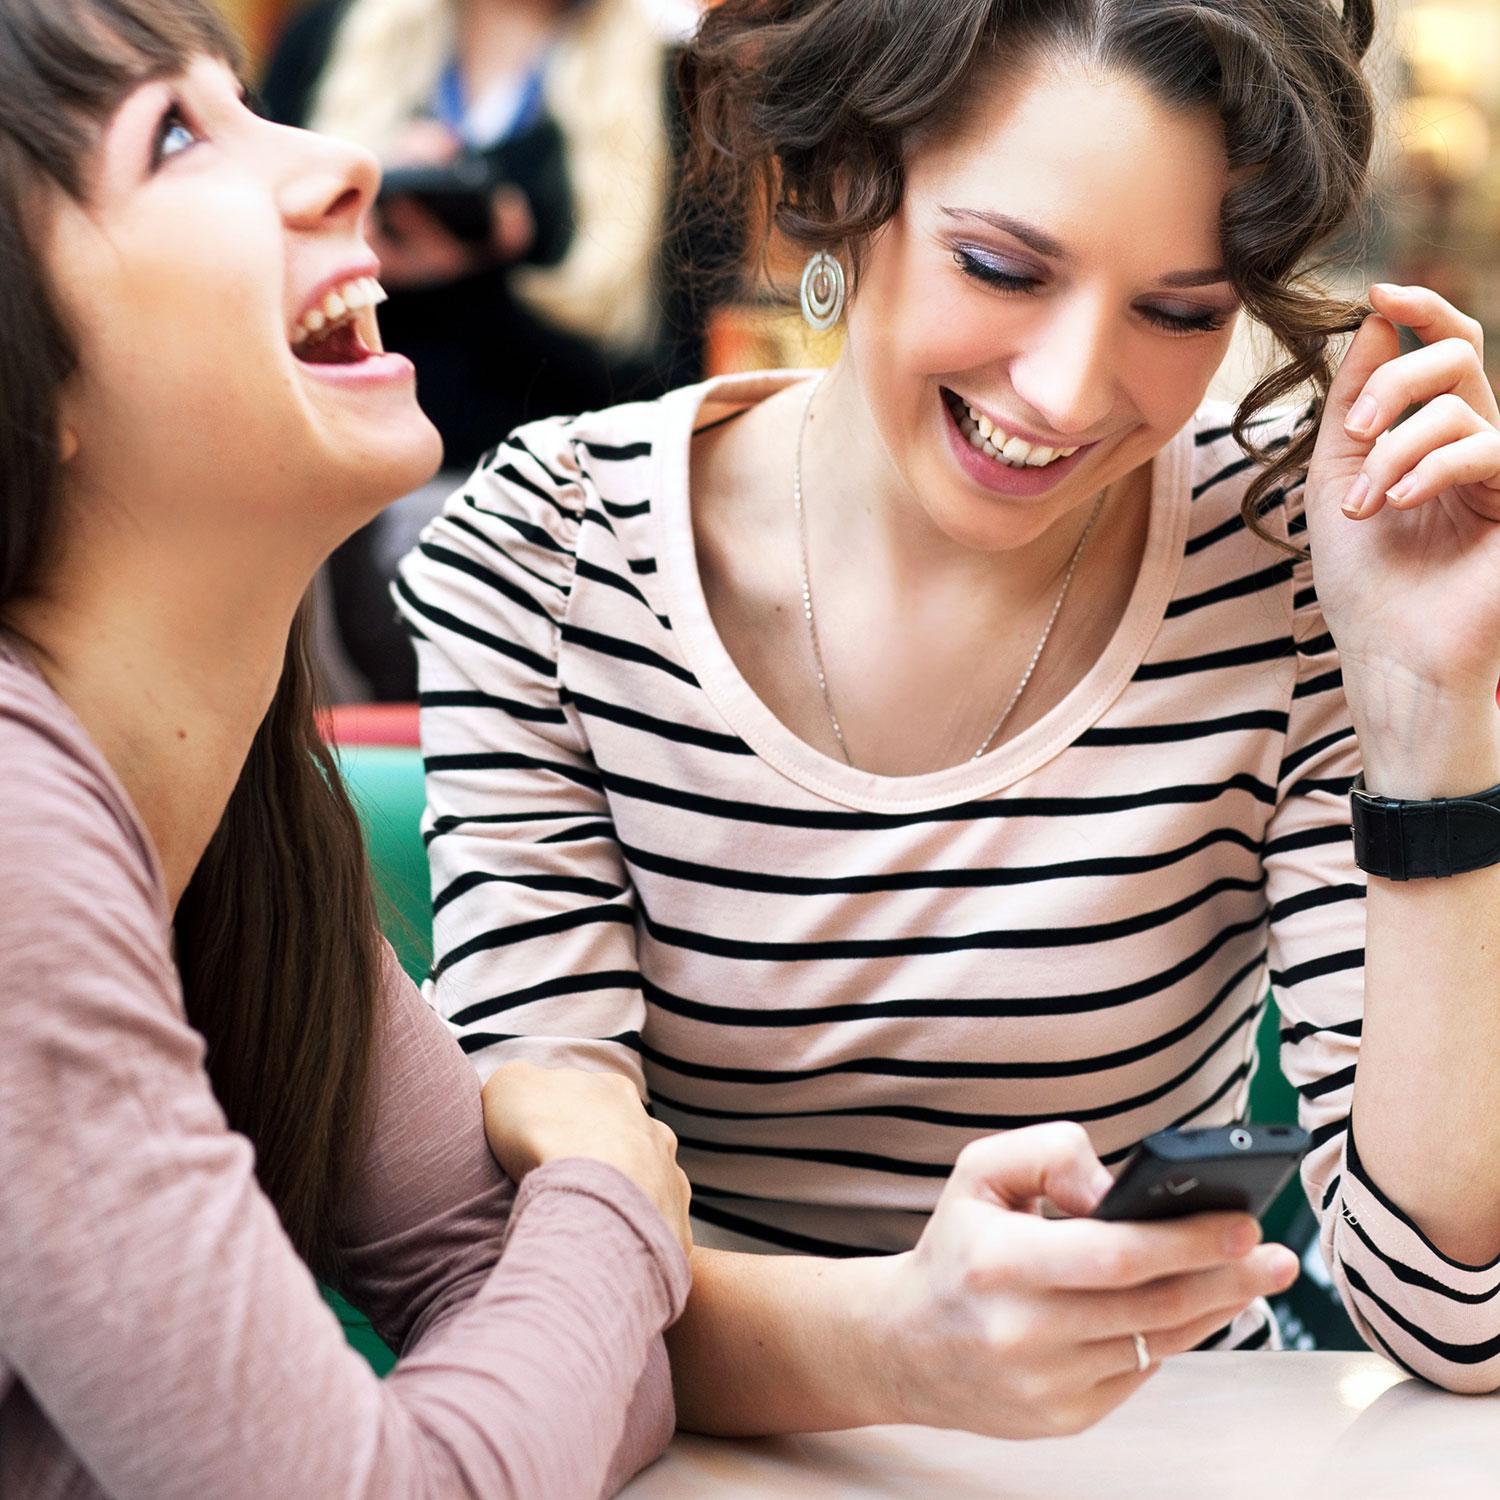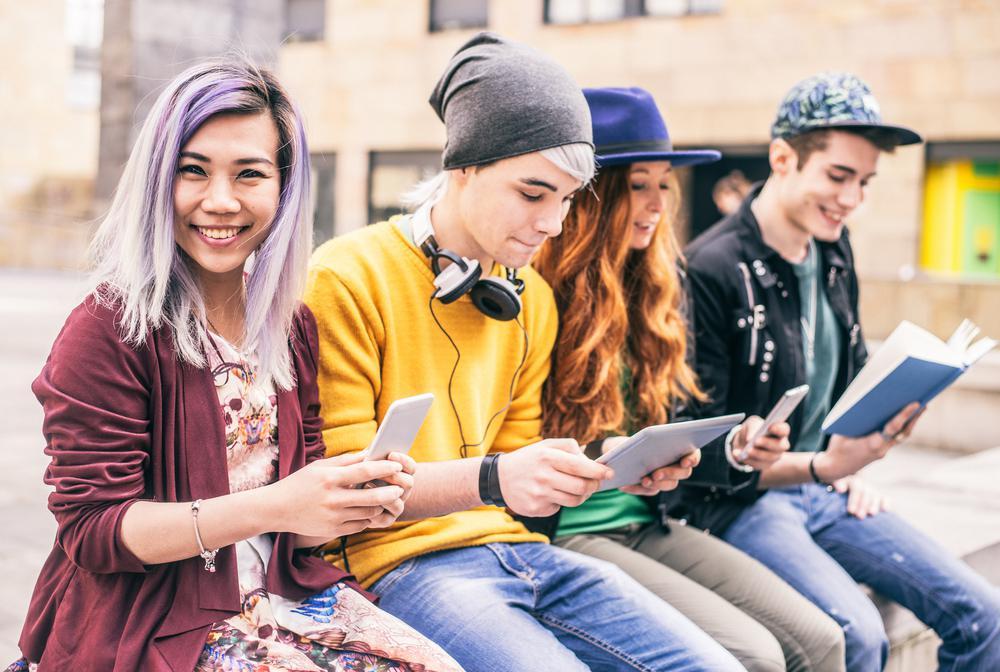The first image is the image on the left, the second image is the image on the right. Given the left and right images, does the statement "There are at most five people in the image pair." hold true? Answer yes or no. No. 